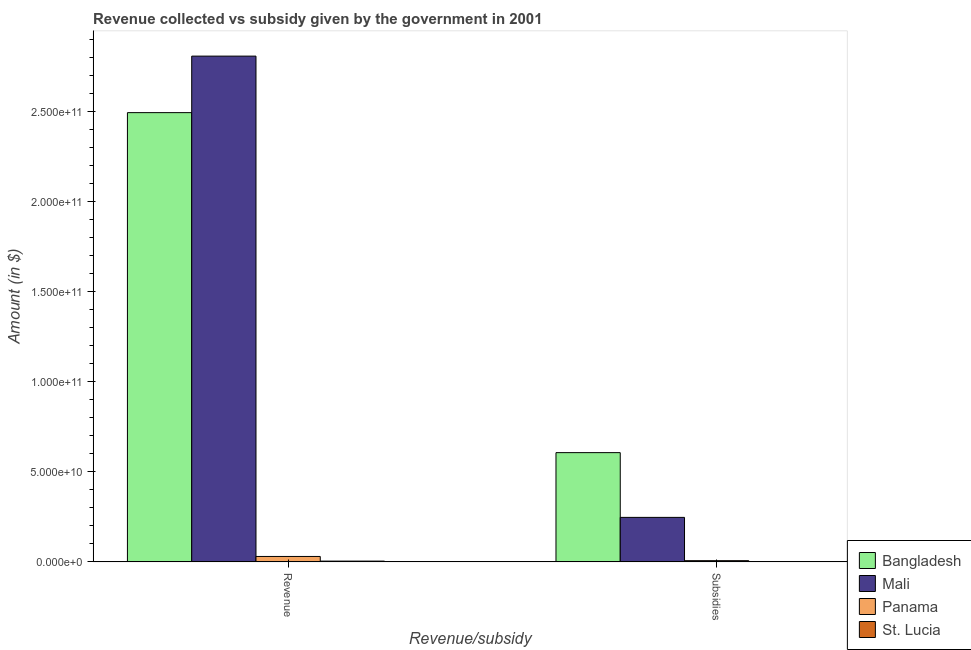How many groups of bars are there?
Provide a succinct answer. 2. Are the number of bars on each tick of the X-axis equal?
Keep it short and to the point. Yes. How many bars are there on the 1st tick from the right?
Offer a very short reply. 4. What is the label of the 2nd group of bars from the left?
Offer a very short reply. Subsidies. What is the amount of subsidies given in Mali?
Offer a very short reply. 2.47e+1. Across all countries, what is the maximum amount of revenue collected?
Provide a succinct answer. 2.81e+11. Across all countries, what is the minimum amount of revenue collected?
Provide a succinct answer. 4.42e+08. In which country was the amount of revenue collected maximum?
Your answer should be compact. Mali. In which country was the amount of subsidies given minimum?
Make the answer very short. St. Lucia. What is the total amount of subsidies given in the graph?
Make the answer very short. 8.61e+1. What is the difference between the amount of subsidies given in St. Lucia and that in Bangladesh?
Make the answer very short. -6.06e+1. What is the difference between the amount of revenue collected in St. Lucia and the amount of subsidies given in Mali?
Keep it short and to the point. -2.43e+1. What is the average amount of revenue collected per country?
Offer a very short reply. 1.33e+11. What is the difference between the amount of subsidies given and amount of revenue collected in Bangladesh?
Keep it short and to the point. -1.89e+11. In how many countries, is the amount of subsidies given greater than 220000000000 $?
Offer a very short reply. 0. What is the ratio of the amount of revenue collected in Mali to that in St. Lucia?
Ensure brevity in your answer.  634.4. What does the 2nd bar from the left in Subsidies represents?
Give a very brief answer. Mali. What does the 3rd bar from the right in Subsidies represents?
Make the answer very short. Mali. How many bars are there?
Your answer should be very brief. 8. How many countries are there in the graph?
Your answer should be compact. 4. What is the difference between two consecutive major ticks on the Y-axis?
Ensure brevity in your answer.  5.00e+1. Are the values on the major ticks of Y-axis written in scientific E-notation?
Your answer should be very brief. Yes. Where does the legend appear in the graph?
Provide a succinct answer. Bottom right. How many legend labels are there?
Provide a succinct answer. 4. How are the legend labels stacked?
Keep it short and to the point. Vertical. What is the title of the graph?
Offer a very short reply. Revenue collected vs subsidy given by the government in 2001. Does "Morocco" appear as one of the legend labels in the graph?
Provide a succinct answer. No. What is the label or title of the X-axis?
Keep it short and to the point. Revenue/subsidy. What is the label or title of the Y-axis?
Your answer should be very brief. Amount (in $). What is the Amount (in $) of Bangladesh in Revenue?
Your answer should be very brief. 2.49e+11. What is the Amount (in $) of Mali in Revenue?
Ensure brevity in your answer.  2.81e+11. What is the Amount (in $) of Panama in Revenue?
Make the answer very short. 3.02e+09. What is the Amount (in $) in St. Lucia in Revenue?
Your response must be concise. 4.42e+08. What is the Amount (in $) of Bangladesh in Subsidies?
Offer a terse response. 6.06e+1. What is the Amount (in $) in Mali in Subsidies?
Give a very brief answer. 2.47e+1. What is the Amount (in $) in Panama in Subsidies?
Ensure brevity in your answer.  6.84e+08. What is the Amount (in $) in St. Lucia in Subsidies?
Offer a very short reply. 7.10e+07. Across all Revenue/subsidy, what is the maximum Amount (in $) in Bangladesh?
Keep it short and to the point. 2.49e+11. Across all Revenue/subsidy, what is the maximum Amount (in $) in Mali?
Your response must be concise. 2.81e+11. Across all Revenue/subsidy, what is the maximum Amount (in $) of Panama?
Ensure brevity in your answer.  3.02e+09. Across all Revenue/subsidy, what is the maximum Amount (in $) in St. Lucia?
Ensure brevity in your answer.  4.42e+08. Across all Revenue/subsidy, what is the minimum Amount (in $) in Bangladesh?
Your answer should be compact. 6.06e+1. Across all Revenue/subsidy, what is the minimum Amount (in $) in Mali?
Give a very brief answer. 2.47e+1. Across all Revenue/subsidy, what is the minimum Amount (in $) of Panama?
Provide a short and direct response. 6.84e+08. Across all Revenue/subsidy, what is the minimum Amount (in $) of St. Lucia?
Keep it short and to the point. 7.10e+07. What is the total Amount (in $) in Bangladesh in the graph?
Your answer should be very brief. 3.10e+11. What is the total Amount (in $) in Mali in the graph?
Give a very brief answer. 3.05e+11. What is the total Amount (in $) in Panama in the graph?
Offer a very short reply. 3.70e+09. What is the total Amount (in $) in St. Lucia in the graph?
Provide a short and direct response. 5.13e+08. What is the difference between the Amount (in $) in Bangladesh in Revenue and that in Subsidies?
Offer a terse response. 1.89e+11. What is the difference between the Amount (in $) in Mali in Revenue and that in Subsidies?
Your answer should be compact. 2.56e+11. What is the difference between the Amount (in $) of Panama in Revenue and that in Subsidies?
Keep it short and to the point. 2.33e+09. What is the difference between the Amount (in $) in St. Lucia in Revenue and that in Subsidies?
Provide a succinct answer. 3.71e+08. What is the difference between the Amount (in $) of Bangladesh in Revenue and the Amount (in $) of Mali in Subsidies?
Your answer should be compact. 2.25e+11. What is the difference between the Amount (in $) in Bangladesh in Revenue and the Amount (in $) in Panama in Subsidies?
Your answer should be compact. 2.49e+11. What is the difference between the Amount (in $) in Bangladesh in Revenue and the Amount (in $) in St. Lucia in Subsidies?
Offer a very short reply. 2.49e+11. What is the difference between the Amount (in $) in Mali in Revenue and the Amount (in $) in Panama in Subsidies?
Your response must be concise. 2.80e+11. What is the difference between the Amount (in $) in Mali in Revenue and the Amount (in $) in St. Lucia in Subsidies?
Offer a terse response. 2.81e+11. What is the difference between the Amount (in $) in Panama in Revenue and the Amount (in $) in St. Lucia in Subsidies?
Provide a succinct answer. 2.95e+09. What is the average Amount (in $) of Bangladesh per Revenue/subsidy?
Provide a short and direct response. 1.55e+11. What is the average Amount (in $) in Mali per Revenue/subsidy?
Your response must be concise. 1.53e+11. What is the average Amount (in $) in Panama per Revenue/subsidy?
Your response must be concise. 1.85e+09. What is the average Amount (in $) of St. Lucia per Revenue/subsidy?
Offer a terse response. 2.57e+08. What is the difference between the Amount (in $) of Bangladesh and Amount (in $) of Mali in Revenue?
Provide a short and direct response. -3.14e+1. What is the difference between the Amount (in $) of Bangladesh and Amount (in $) of Panama in Revenue?
Offer a terse response. 2.46e+11. What is the difference between the Amount (in $) of Bangladesh and Amount (in $) of St. Lucia in Revenue?
Your response must be concise. 2.49e+11. What is the difference between the Amount (in $) of Mali and Amount (in $) of Panama in Revenue?
Keep it short and to the point. 2.78e+11. What is the difference between the Amount (in $) of Mali and Amount (in $) of St. Lucia in Revenue?
Offer a terse response. 2.80e+11. What is the difference between the Amount (in $) in Panama and Amount (in $) in St. Lucia in Revenue?
Ensure brevity in your answer.  2.58e+09. What is the difference between the Amount (in $) of Bangladesh and Amount (in $) of Mali in Subsidies?
Keep it short and to the point. 3.59e+1. What is the difference between the Amount (in $) of Bangladesh and Amount (in $) of Panama in Subsidies?
Make the answer very short. 5.99e+1. What is the difference between the Amount (in $) in Bangladesh and Amount (in $) in St. Lucia in Subsidies?
Give a very brief answer. 6.06e+1. What is the difference between the Amount (in $) of Mali and Amount (in $) of Panama in Subsidies?
Offer a very short reply. 2.40e+1. What is the difference between the Amount (in $) of Mali and Amount (in $) of St. Lucia in Subsidies?
Offer a terse response. 2.46e+1. What is the difference between the Amount (in $) in Panama and Amount (in $) in St. Lucia in Subsidies?
Give a very brief answer. 6.13e+08. What is the ratio of the Amount (in $) of Bangladesh in Revenue to that in Subsidies?
Keep it short and to the point. 4.11. What is the ratio of the Amount (in $) of Mali in Revenue to that in Subsidies?
Offer a terse response. 11.36. What is the ratio of the Amount (in $) in Panama in Revenue to that in Subsidies?
Your answer should be compact. 4.41. What is the ratio of the Amount (in $) in St. Lucia in Revenue to that in Subsidies?
Ensure brevity in your answer.  6.23. What is the difference between the highest and the second highest Amount (in $) of Bangladesh?
Offer a terse response. 1.89e+11. What is the difference between the highest and the second highest Amount (in $) of Mali?
Your answer should be compact. 2.56e+11. What is the difference between the highest and the second highest Amount (in $) in Panama?
Make the answer very short. 2.33e+09. What is the difference between the highest and the second highest Amount (in $) of St. Lucia?
Your answer should be compact. 3.71e+08. What is the difference between the highest and the lowest Amount (in $) of Bangladesh?
Your response must be concise. 1.89e+11. What is the difference between the highest and the lowest Amount (in $) of Mali?
Your response must be concise. 2.56e+11. What is the difference between the highest and the lowest Amount (in $) of Panama?
Give a very brief answer. 2.33e+09. What is the difference between the highest and the lowest Amount (in $) of St. Lucia?
Your answer should be compact. 3.71e+08. 